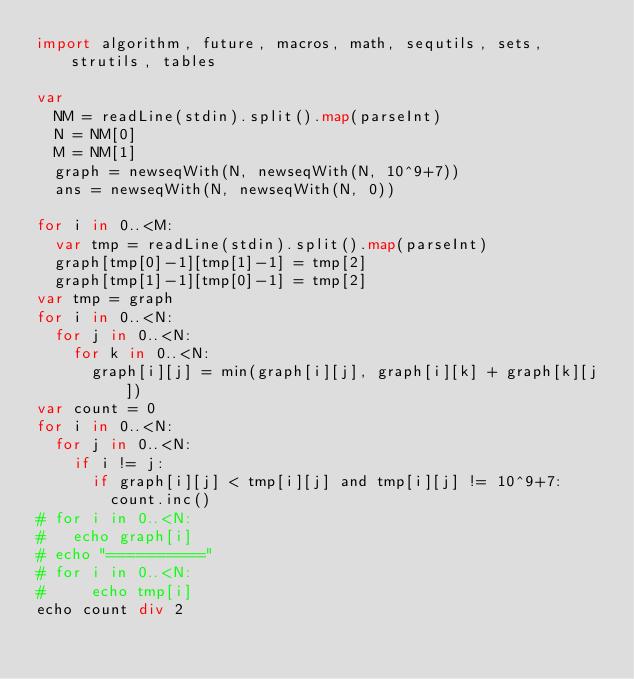<code> <loc_0><loc_0><loc_500><loc_500><_Nim_>import algorithm, future, macros, math, sequtils, sets, strutils, tables

var
  NM = readLine(stdin).split().map(parseInt)
  N = NM[0]
  M = NM[1]
  graph = newseqWith(N, newseqWith(N, 10^9+7))
  ans = newseqWith(N, newseqWith(N, 0))

for i in 0..<M:
  var tmp = readLine(stdin).split().map(parseInt)
  graph[tmp[0]-1][tmp[1]-1] = tmp[2]
  graph[tmp[1]-1][tmp[0]-1] = tmp[2]
var tmp = graph
for i in 0..<N:
  for j in 0..<N:
    for k in 0..<N:
      graph[i][j] = min(graph[i][j], graph[i][k] + graph[k][j])
var count = 0
for i in 0..<N:
  for j in 0..<N:
    if i != j:
      if graph[i][j] < tmp[i][j] and tmp[i][j] != 10^9+7:
        count.inc()
# for i in 0..<N:
#   echo graph[i]
# echo "=========="
# for i in 0..<N:
#     echo tmp[i]
echo count div 2</code> 